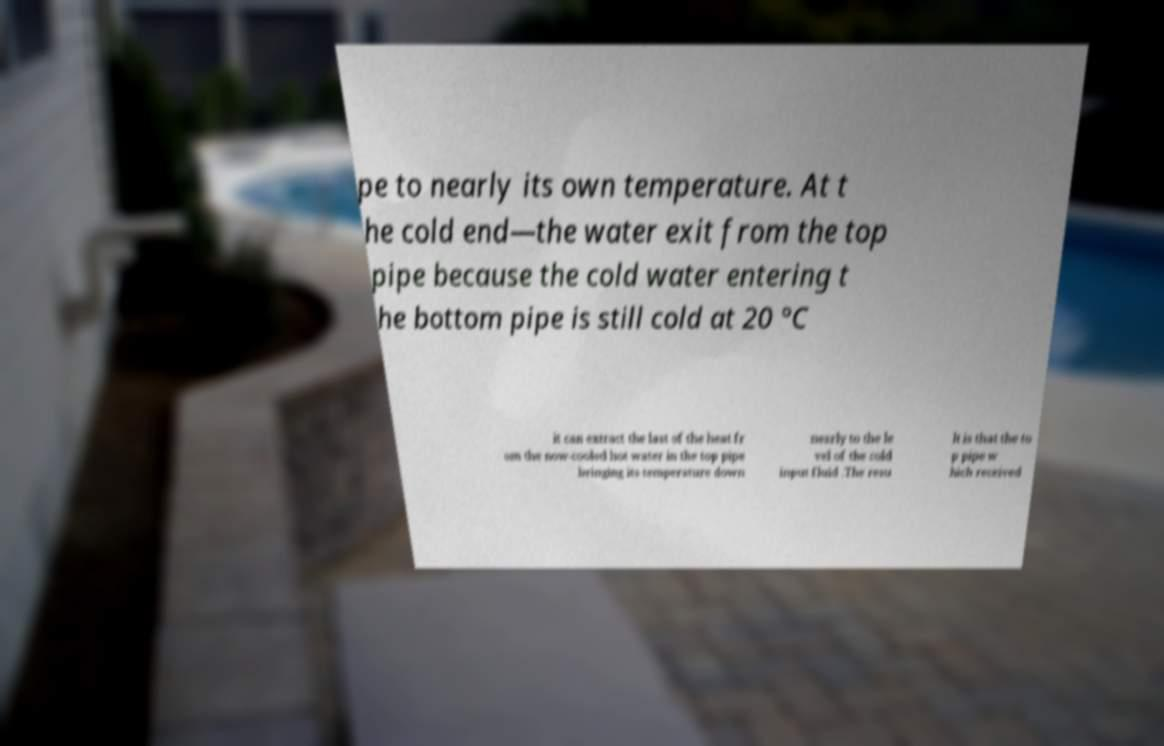There's text embedded in this image that I need extracted. Can you transcribe it verbatim? pe to nearly its own temperature. At t he cold end—the water exit from the top pipe because the cold water entering t he bottom pipe is still cold at 20 °C it can extract the last of the heat fr om the now-cooled hot water in the top pipe bringing its temperature down nearly to the le vel of the cold input fluid .The resu lt is that the to p pipe w hich received 